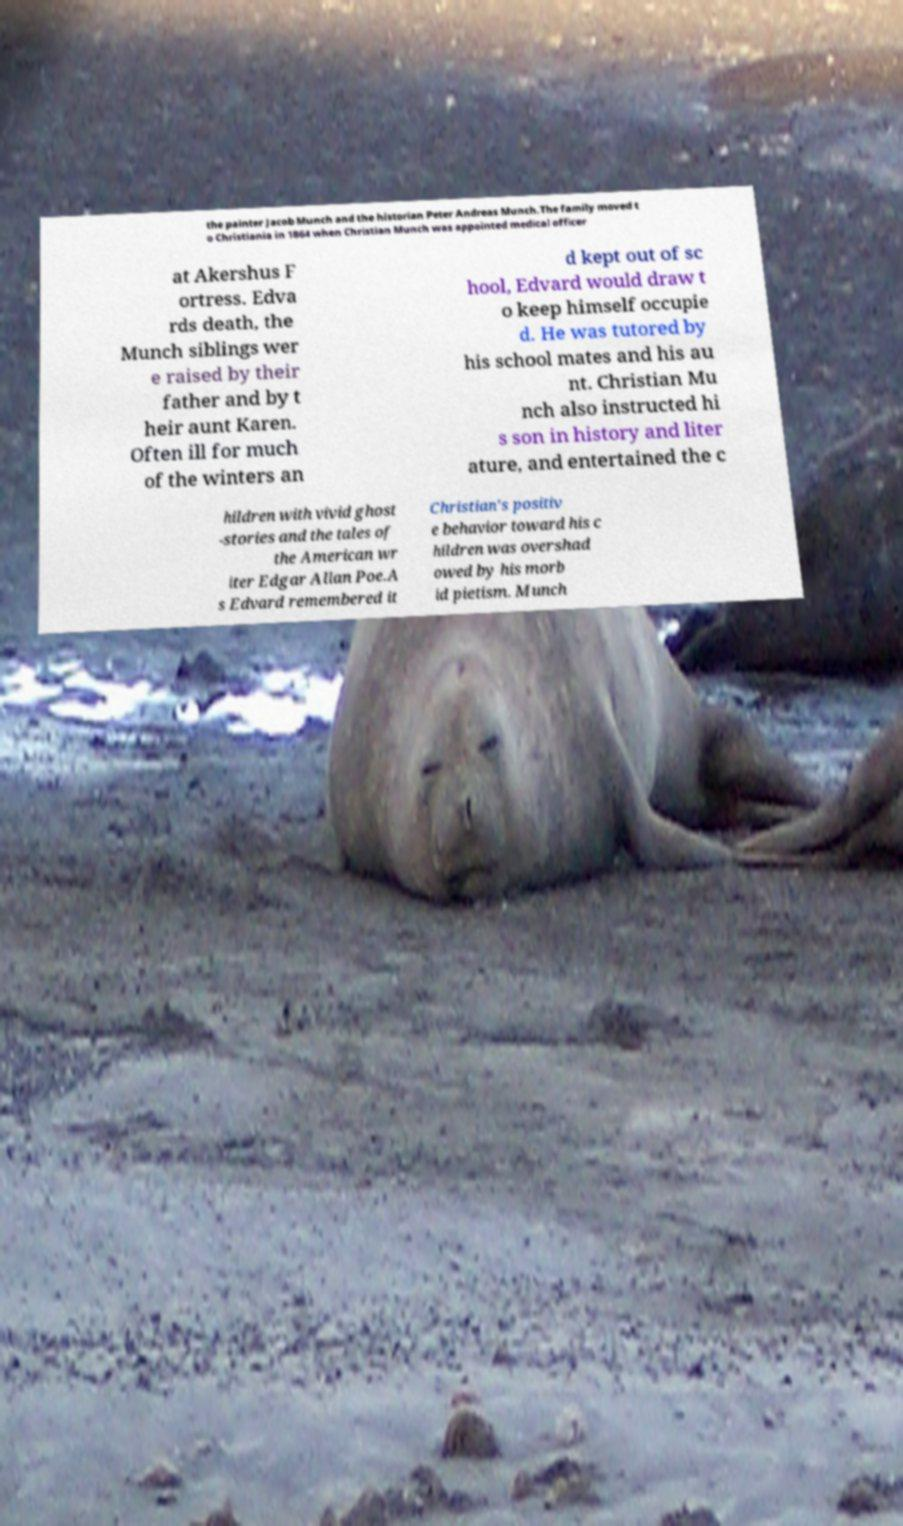Could you assist in decoding the text presented in this image and type it out clearly? the painter Jacob Munch and the historian Peter Andreas Munch.The family moved t o Christiania in 1864 when Christian Munch was appointed medical officer at Akershus F ortress. Edva rds death, the Munch siblings wer e raised by their father and by t heir aunt Karen. Often ill for much of the winters an d kept out of sc hool, Edvard would draw t o keep himself occupie d. He was tutored by his school mates and his au nt. Christian Mu nch also instructed hi s son in history and liter ature, and entertained the c hildren with vivid ghost -stories and the tales of the American wr iter Edgar Allan Poe.A s Edvard remembered it Christian's positiv e behavior toward his c hildren was overshad owed by his morb id pietism. Munch 